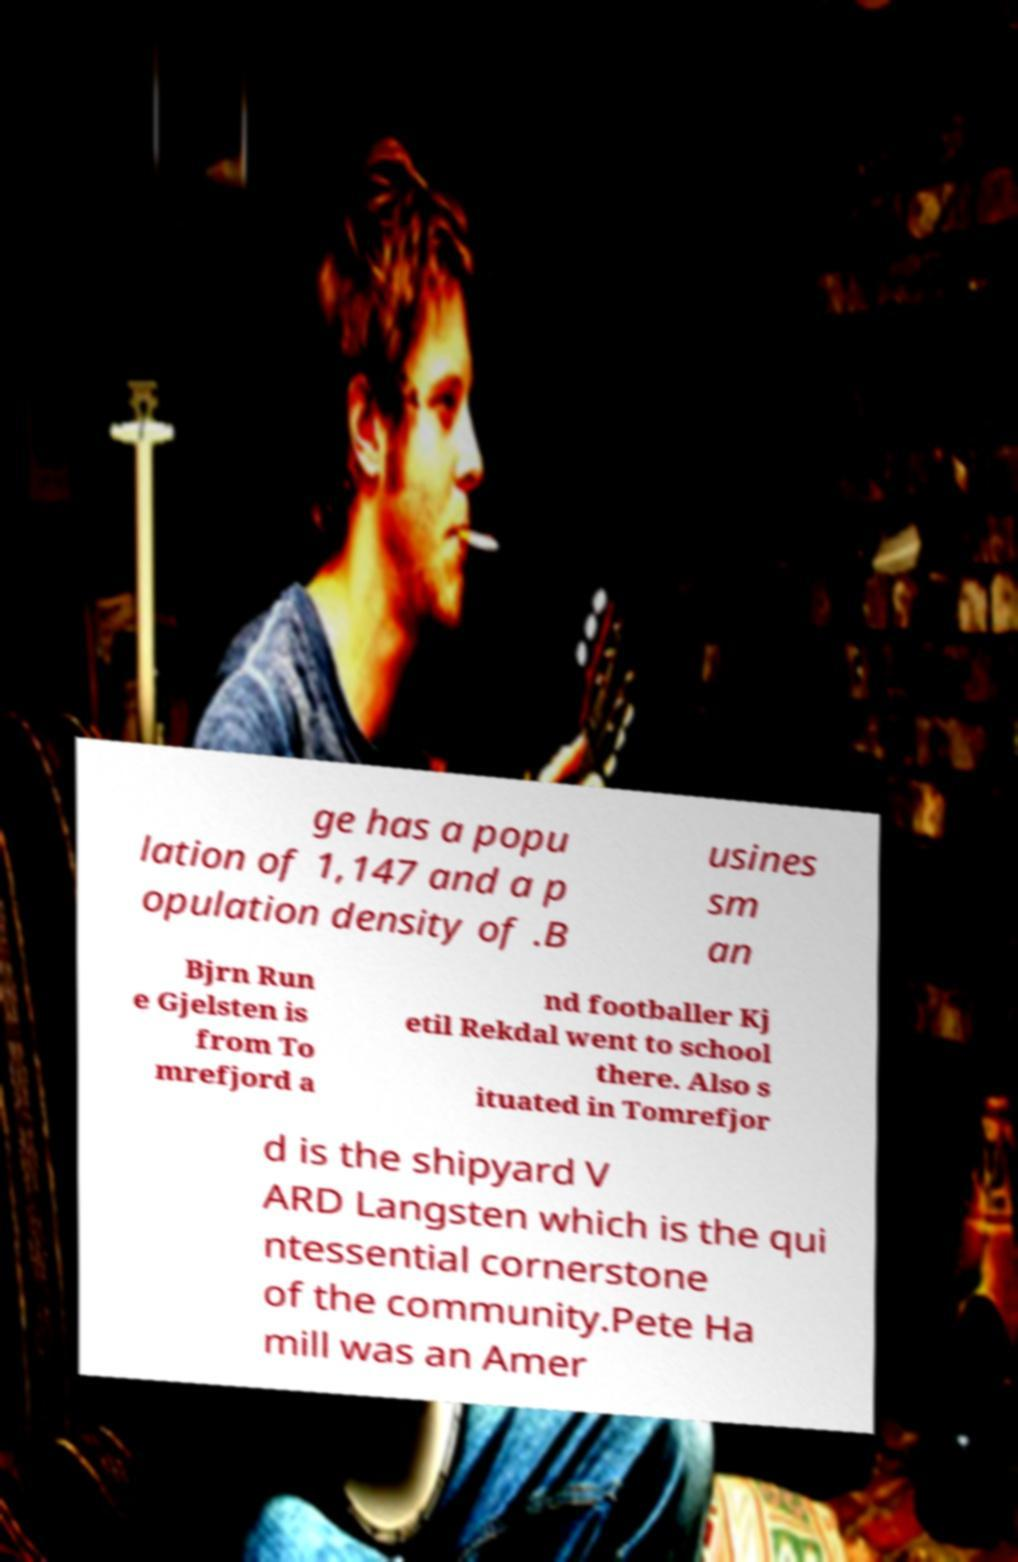Please read and relay the text visible in this image. What does it say? ge has a popu lation of 1,147 and a p opulation density of .B usines sm an Bjrn Run e Gjelsten is from To mrefjord a nd footballer Kj etil Rekdal went to school there. Also s ituated in Tomrefjor d is the shipyard V ARD Langsten which is the qui ntessential cornerstone of the community.Pete Ha mill was an Amer 